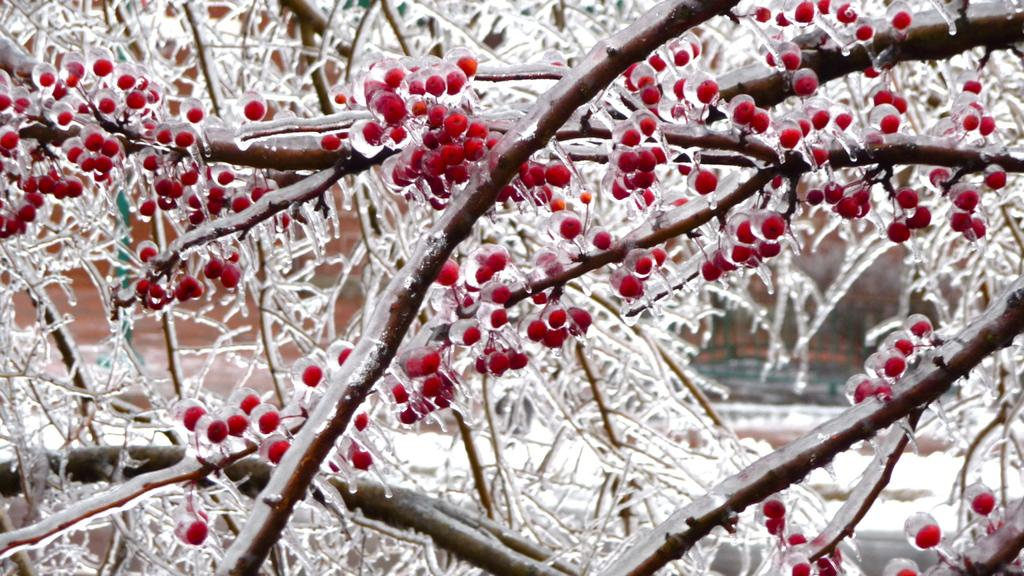What is located in the foreground of the image? There is a tree in the foreground of the image. What can be seen in the image besides the tree? There are fruits visible in the image. How would you describe the background of the image? The background of the image is blurry. Where is the toothbrush located in the image? There is no toothbrush present in the image. What type of unit is visible in the image? There is no unit present in the image. 